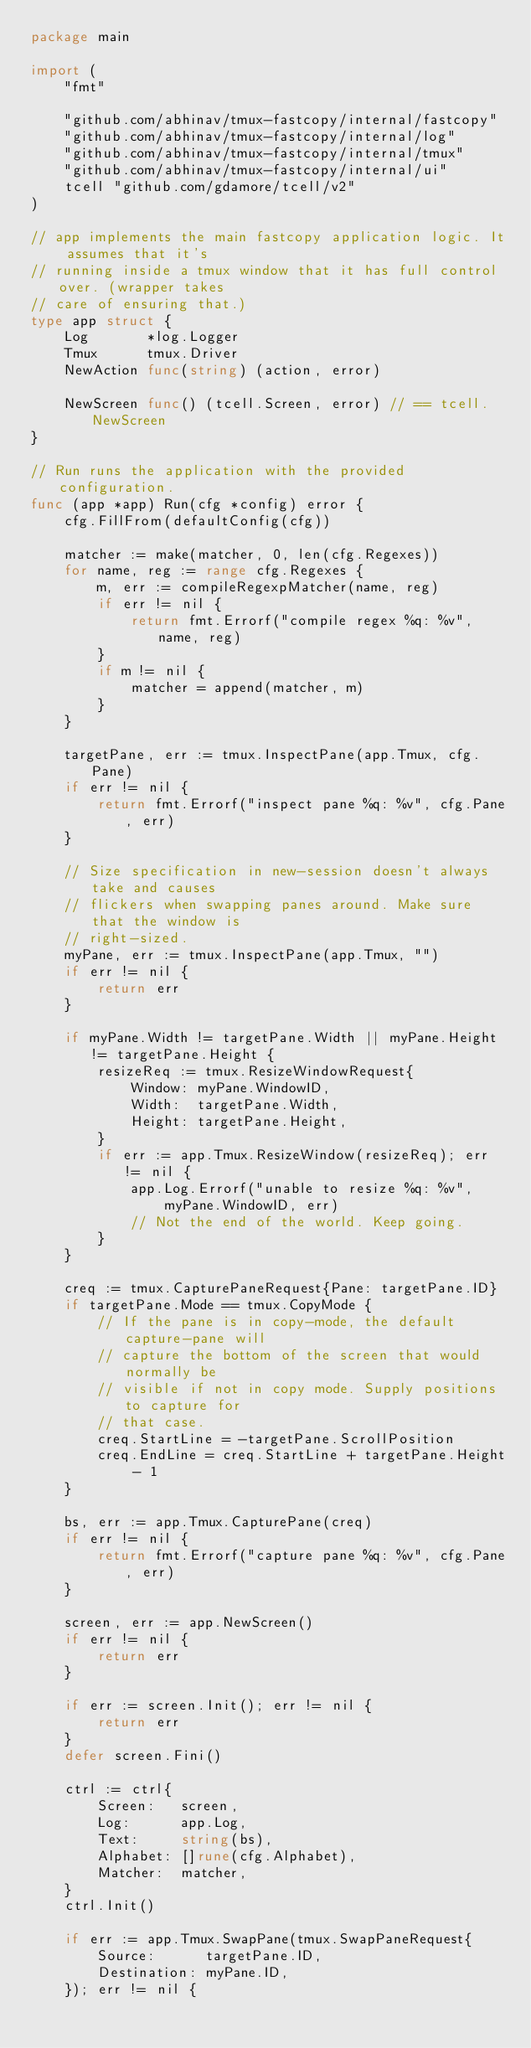Convert code to text. <code><loc_0><loc_0><loc_500><loc_500><_Go_>package main

import (
	"fmt"

	"github.com/abhinav/tmux-fastcopy/internal/fastcopy"
	"github.com/abhinav/tmux-fastcopy/internal/log"
	"github.com/abhinav/tmux-fastcopy/internal/tmux"
	"github.com/abhinav/tmux-fastcopy/internal/ui"
	tcell "github.com/gdamore/tcell/v2"
)

// app implements the main fastcopy application logic. It assumes that it's
// running inside a tmux window that it has full control over. (wrapper takes
// care of ensuring that.)
type app struct {
	Log       *log.Logger
	Tmux      tmux.Driver
	NewAction func(string) (action, error)

	NewScreen func() (tcell.Screen, error) // == tcell.NewScreen
}

// Run runs the application with the provided configuration.
func (app *app) Run(cfg *config) error {
	cfg.FillFrom(defaultConfig(cfg))

	matcher := make(matcher, 0, len(cfg.Regexes))
	for name, reg := range cfg.Regexes {
		m, err := compileRegexpMatcher(name, reg)
		if err != nil {
			return fmt.Errorf("compile regex %q: %v", name, reg)
		}
		if m != nil {
			matcher = append(matcher, m)
		}
	}

	targetPane, err := tmux.InspectPane(app.Tmux, cfg.Pane)
	if err != nil {
		return fmt.Errorf("inspect pane %q: %v", cfg.Pane, err)
	}

	// Size specification in new-session doesn't always take and causes
	// flickers when swapping panes around. Make sure that the window is
	// right-sized.
	myPane, err := tmux.InspectPane(app.Tmux, "")
	if err != nil {
		return err
	}

	if myPane.Width != targetPane.Width || myPane.Height != targetPane.Height {
		resizeReq := tmux.ResizeWindowRequest{
			Window: myPane.WindowID,
			Width:  targetPane.Width,
			Height: targetPane.Height,
		}
		if err := app.Tmux.ResizeWindow(resizeReq); err != nil {
			app.Log.Errorf("unable to resize %q: %v",
				myPane.WindowID, err)
			// Not the end of the world. Keep going.
		}
	}

	creq := tmux.CapturePaneRequest{Pane: targetPane.ID}
	if targetPane.Mode == tmux.CopyMode {
		// If the pane is in copy-mode, the default capture-pane will
		// capture the bottom of the screen that would normally be
		// visible if not in copy mode. Supply positions to capture for
		// that case.
		creq.StartLine = -targetPane.ScrollPosition
		creq.EndLine = creq.StartLine + targetPane.Height - 1
	}

	bs, err := app.Tmux.CapturePane(creq)
	if err != nil {
		return fmt.Errorf("capture pane %q: %v", cfg.Pane, err)
	}

	screen, err := app.NewScreen()
	if err != nil {
		return err
	}

	if err := screen.Init(); err != nil {
		return err
	}
	defer screen.Fini()

	ctrl := ctrl{
		Screen:   screen,
		Log:      app.Log,
		Text:     string(bs),
		Alphabet: []rune(cfg.Alphabet),
		Matcher:  matcher,
	}
	ctrl.Init()

	if err := app.Tmux.SwapPane(tmux.SwapPaneRequest{
		Source:      targetPane.ID,
		Destination: myPane.ID,
	}); err != nil {</code> 